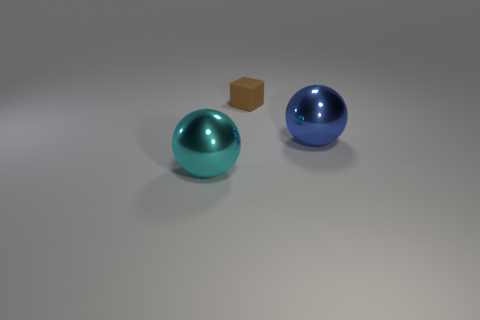Are there any other things that are the same size as the brown rubber object?
Offer a terse response. No. Is there anything else that has the same material as the brown thing?
Provide a short and direct response. No. Are the big sphere to the left of the brown thing and the large object that is behind the large cyan metal ball made of the same material?
Offer a very short reply. Yes. How many rubber objects are cyan balls or large cyan cylinders?
Offer a terse response. 0. There is a big sphere to the right of the metallic thing left of the big thing behind the big cyan sphere; what is it made of?
Make the answer very short. Metal. There is a large thing left of the blue metal ball; is its shape the same as the brown thing that is on the right side of the cyan shiny object?
Make the answer very short. No. There is a tiny thing that is on the right side of the ball on the left side of the big blue metallic thing; what color is it?
Provide a short and direct response. Brown. What number of spheres are either cyan metal things or big shiny things?
Your response must be concise. 2. How many tiny brown blocks are left of the shiny object that is to the right of the brown cube behind the cyan sphere?
Ensure brevity in your answer.  1. Is there another large thing that has the same material as the large cyan thing?
Offer a terse response. Yes. 